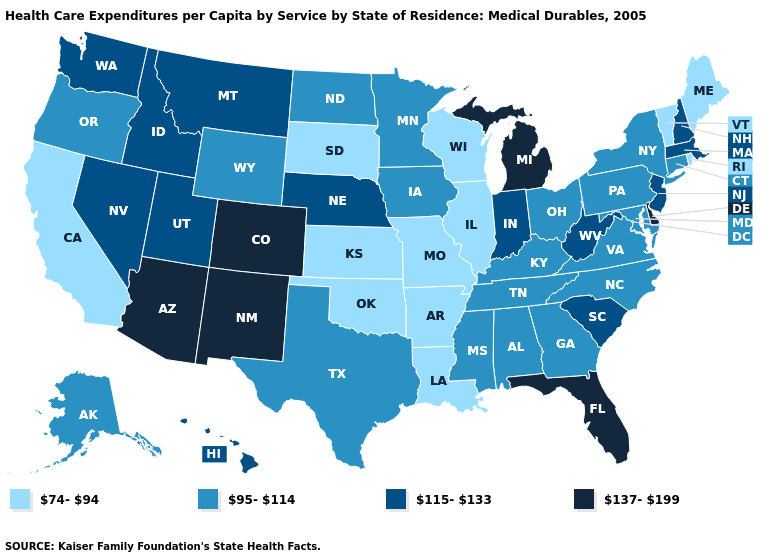Name the states that have a value in the range 74-94?
Quick response, please. Arkansas, California, Illinois, Kansas, Louisiana, Maine, Missouri, Oklahoma, Rhode Island, South Dakota, Vermont, Wisconsin. Does New Mexico have the highest value in the West?
Be succinct. Yes. Does Washington have the highest value in the West?
Keep it brief. No. Does the map have missing data?
Concise answer only. No. Which states have the highest value in the USA?
Keep it brief. Arizona, Colorado, Delaware, Florida, Michigan, New Mexico. Among the states that border Connecticut , does Rhode Island have the lowest value?
Quick response, please. Yes. Among the states that border Connecticut , does Massachusetts have the highest value?
Give a very brief answer. Yes. What is the value of Texas?
Keep it brief. 95-114. Is the legend a continuous bar?
Concise answer only. No. What is the lowest value in states that border Montana?
Quick response, please. 74-94. Name the states that have a value in the range 74-94?
Short answer required. Arkansas, California, Illinois, Kansas, Louisiana, Maine, Missouri, Oklahoma, Rhode Island, South Dakota, Vermont, Wisconsin. Does the first symbol in the legend represent the smallest category?
Short answer required. Yes. What is the highest value in the MidWest ?
Concise answer only. 137-199. What is the lowest value in states that border Kentucky?
Be succinct. 74-94. Does the first symbol in the legend represent the smallest category?
Write a very short answer. Yes. 